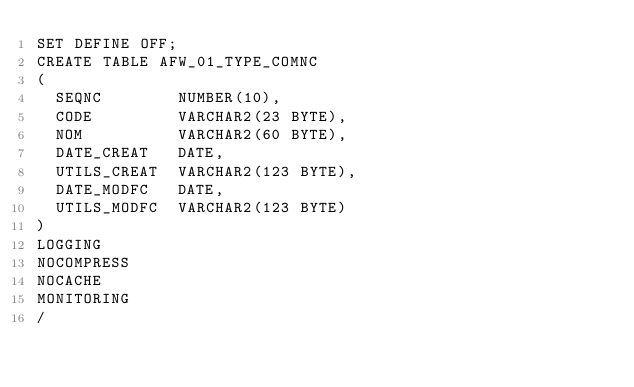Convert code to text. <code><loc_0><loc_0><loc_500><loc_500><_SQL_>SET DEFINE OFF;
CREATE TABLE AFW_01_TYPE_COMNC
(
  SEQNC        NUMBER(10),
  CODE         VARCHAR2(23 BYTE),
  NOM          VARCHAR2(60 BYTE),
  DATE_CREAT   DATE,
  UTILS_CREAT  VARCHAR2(123 BYTE),
  DATE_MODFC   DATE,
  UTILS_MODFC  VARCHAR2(123 BYTE)
)
LOGGING 
NOCOMPRESS 
NOCACHE
MONITORING
/
</code> 